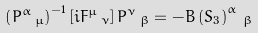Convert formula to latex. <formula><loc_0><loc_0><loc_500><loc_500>\left ( P ^ { \alpha } \, _ { \mu } \right ) ^ { - 1 } \left [ i F ^ { \mu } \, _ { \nu } \right ] P ^ { \nu } \, _ { \beta } = - B \left ( S _ { 3 } \right ) ^ { \alpha } \, _ { \beta }</formula> 